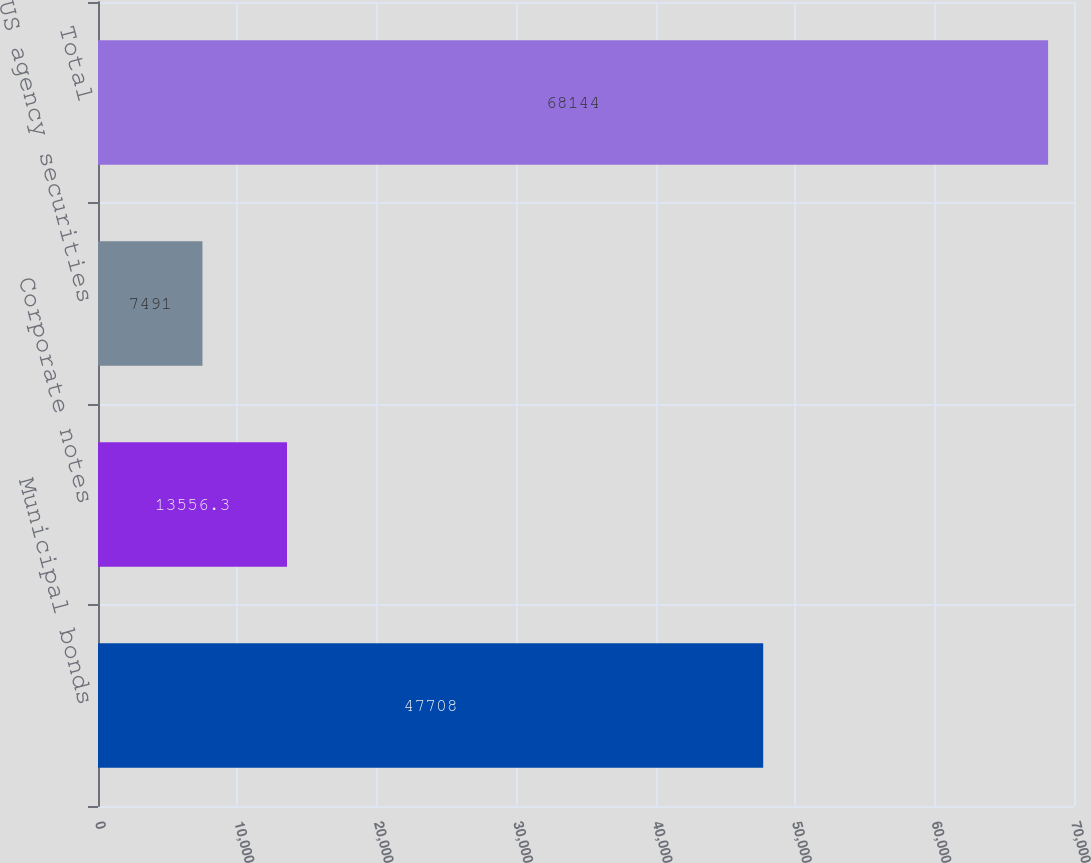<chart> <loc_0><loc_0><loc_500><loc_500><bar_chart><fcel>Municipal bonds<fcel>Corporate notes<fcel>US agency securities<fcel>Total<nl><fcel>47708<fcel>13556.3<fcel>7491<fcel>68144<nl></chart> 